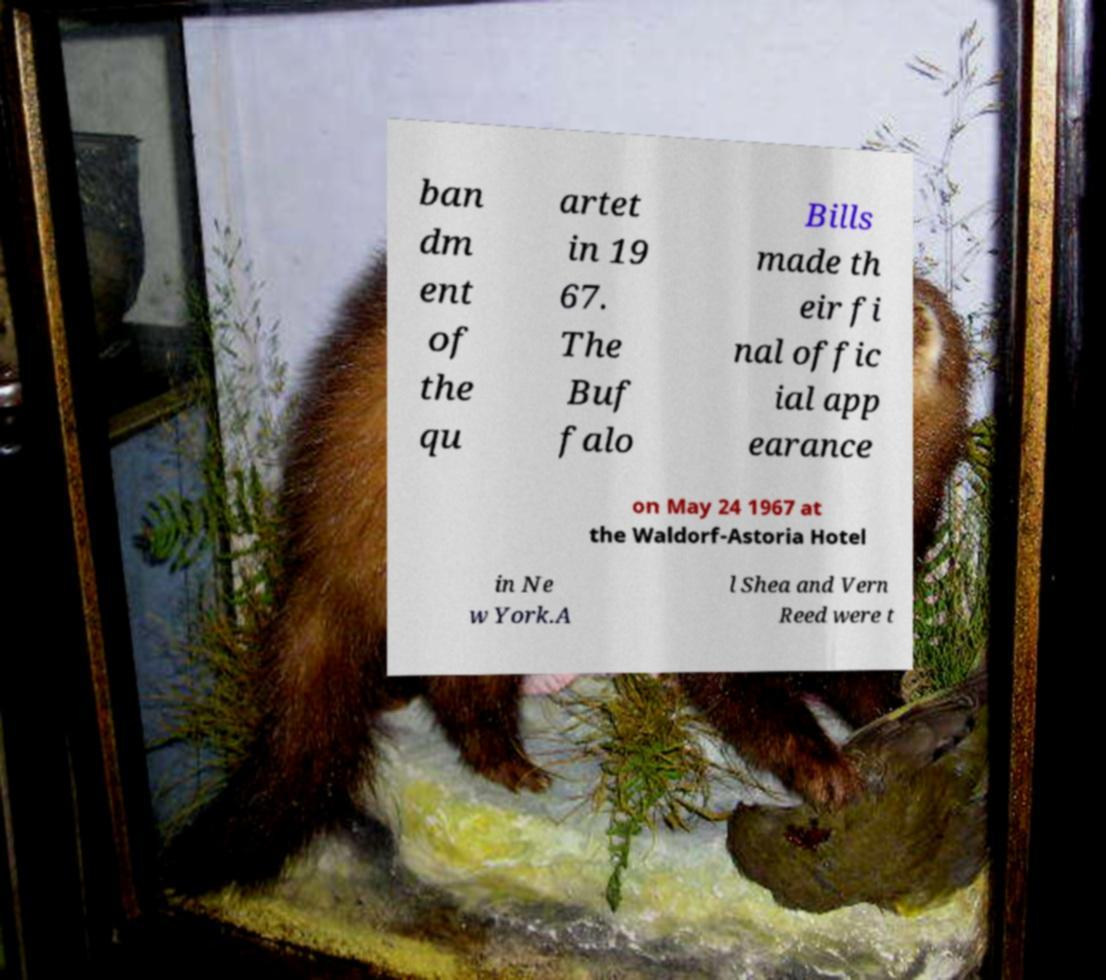Could you assist in decoding the text presented in this image and type it out clearly? ban dm ent of the qu artet in 19 67. The Buf falo Bills made th eir fi nal offic ial app earance on May 24 1967 at the Waldorf-Astoria Hotel in Ne w York.A l Shea and Vern Reed were t 